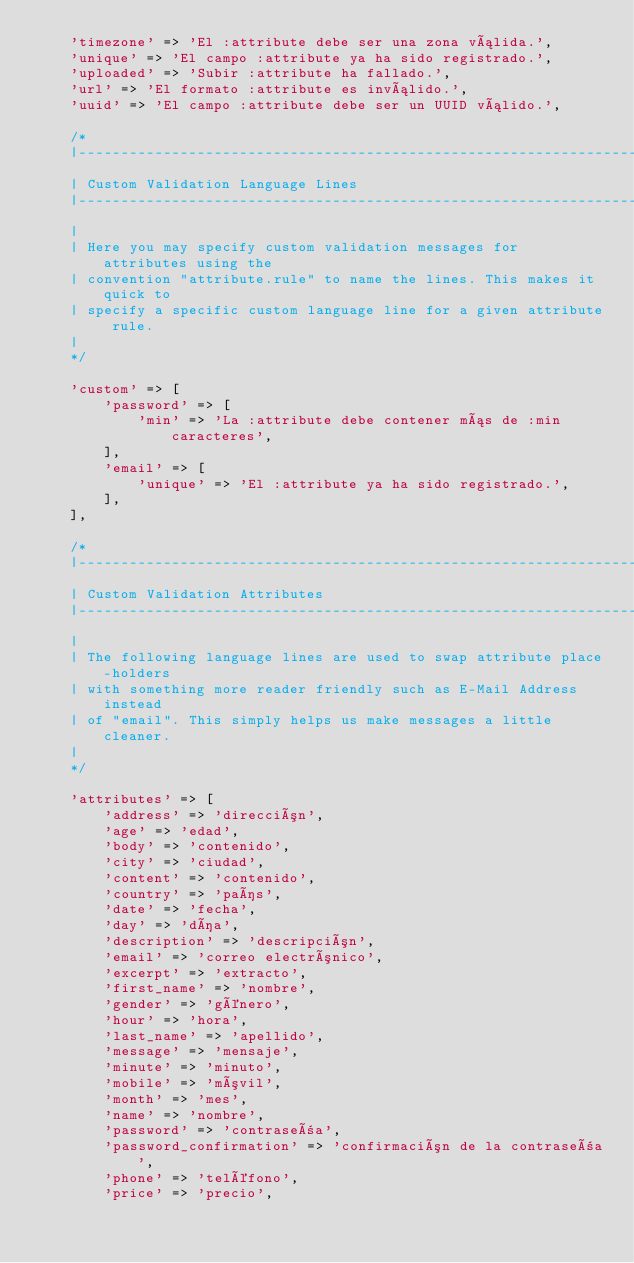<code> <loc_0><loc_0><loc_500><loc_500><_PHP_>    'timezone' => 'El :attribute debe ser una zona válida.',
    'unique' => 'El campo :attribute ya ha sido registrado.',
    'uploaded' => 'Subir :attribute ha fallado.',
    'url' => 'El formato :attribute es inválido.',
    'uuid' => 'El campo :attribute debe ser un UUID válido.',

    /*
    |--------------------------------------------------------------------------
    | Custom Validation Language Lines
    |--------------------------------------------------------------------------
    |
    | Here you may specify custom validation messages for attributes using the
    | convention "attribute.rule" to name the lines. This makes it quick to
    | specify a specific custom language line for a given attribute rule.
    |
    */

    'custom' => [
        'password' => [
            'min' => 'La :attribute debe contener más de :min caracteres',
        ],
        'email' => [
            'unique' => 'El :attribute ya ha sido registrado.',
        ],
    ],

    /*
    |--------------------------------------------------------------------------
    | Custom Validation Attributes
    |--------------------------------------------------------------------------
    |
    | The following language lines are used to swap attribute place-holders
    | with something more reader friendly such as E-Mail Address instead
    | of "email". This simply helps us make messages a little cleaner.
    |
    */

    'attributes' => [
        'address' => 'dirección',
        'age' => 'edad',
        'body' => 'contenido',
        'city' => 'ciudad',
        'content' => 'contenido',
        'country' => 'país',
        'date' => 'fecha',
        'day' => 'día',
        'description' => 'descripción',
        'email' => 'correo electrónico',
        'excerpt' => 'extracto',
        'first_name' => 'nombre',
        'gender' => 'género',
        'hour' => 'hora',
        'last_name' => 'apellido',
        'message' => 'mensaje',
        'minute' => 'minuto',
        'mobile' => 'móvil',
        'month' => 'mes',
        'name' => 'nombre',
        'password' => 'contraseña',
        'password_confirmation' => 'confirmación de la contraseña',
        'phone' => 'teléfono',
        'price' => 'precio',</code> 